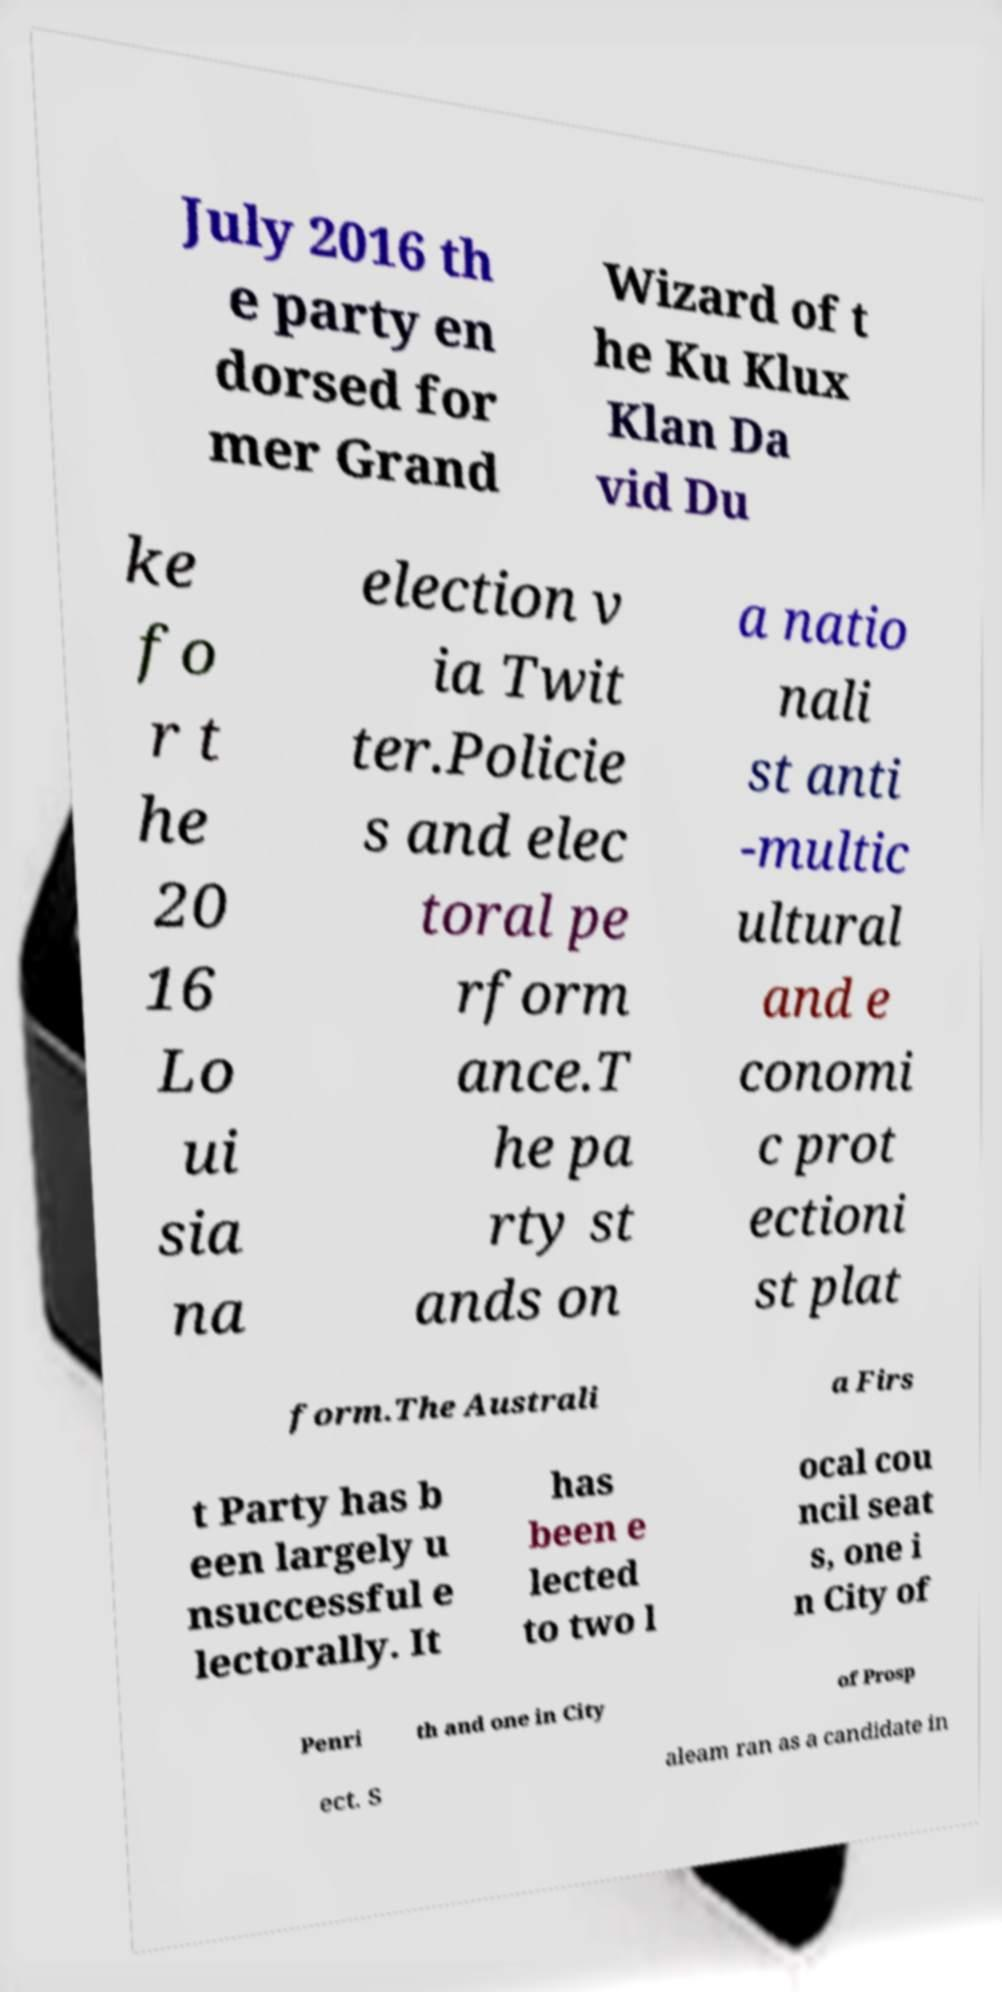What messages or text are displayed in this image? I need them in a readable, typed format. July 2016 th e party en dorsed for mer Grand Wizard of t he Ku Klux Klan Da vid Du ke fo r t he 20 16 Lo ui sia na election v ia Twit ter.Policie s and elec toral pe rform ance.T he pa rty st ands on a natio nali st anti -multic ultural and e conomi c prot ectioni st plat form.The Australi a Firs t Party has b een largely u nsuccessful e lectorally. It has been e lected to two l ocal cou ncil seat s, one i n City of Penri th and one in City of Prosp ect. S aleam ran as a candidate in 